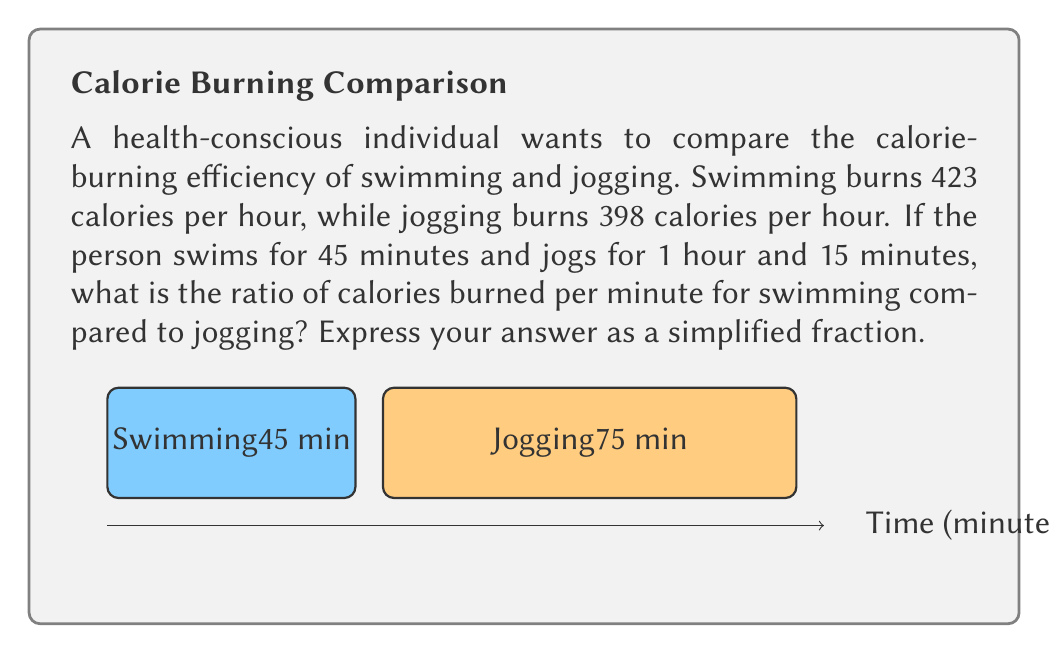Can you solve this math problem? Let's approach this step-by-step:

1) First, calculate the calories burned for each activity:

   Swimming: $423 \text{ cal/hr} \times \frac{45 \text{ min}}{60 \text{ min/hr}} = 316.75 \text{ cal}$
   Jogging: $398 \text{ cal/hr} \times \frac{75 \text{ min}}{60 \text{ min/hr}} = 497.5 \text{ cal}$

2) Now, calculate the calories burned per minute for each activity:

   Swimming: $\frac{316.75 \text{ cal}}{45 \text{ min}} = 7.0389 \text{ cal/min}$
   Jogging: $\frac{497.5 \text{ cal}}{75 \text{ min}} = 6.6333 \text{ cal/min}$

3) The ratio of calories burned per minute for swimming compared to jogging is:

   $\frac{\text{Swimming cal/min}}{\text{Jogging cal/min}} = \frac{7.0389}{6.6333}$

4) To simplify this fraction, we can multiply both numerator and denominator by 10000 to eliminate decimals:

   $\frac{70389}{66333}$

5) This fraction can be further simplified by dividing both numerator and denominator by their greatest common divisor (GCD). The GCD of 70389 and 66333 is 3.

   $\frac{70389 \div 3}{66333 \div 3} = \frac{23463}{22111}$

This is the simplified ratio of calories burned per minute for swimming compared to jogging.
Answer: $\frac{23463}{22111}$ 